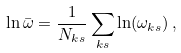Convert formula to latex. <formula><loc_0><loc_0><loc_500><loc_500>\ln \bar { \omega } = \frac { 1 } { N _ { { k } s } } \sum _ { { k } s } \ln ( \omega _ { { k } s } ) \, ,</formula> 